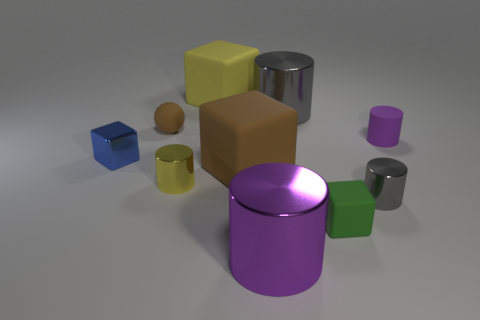Subtract 2 cylinders. How many cylinders are left? 3 Subtract all yellow cylinders. How many cylinders are left? 4 Subtract all purple shiny cylinders. How many cylinders are left? 4 Subtract all green cylinders. Subtract all gray cubes. How many cylinders are left? 5 Subtract all cubes. How many objects are left? 6 Add 1 yellow rubber things. How many yellow rubber things are left? 2 Add 9 big yellow matte blocks. How many big yellow matte blocks exist? 10 Subtract 0 purple spheres. How many objects are left? 10 Subtract all big red matte cylinders. Subtract all green things. How many objects are left? 9 